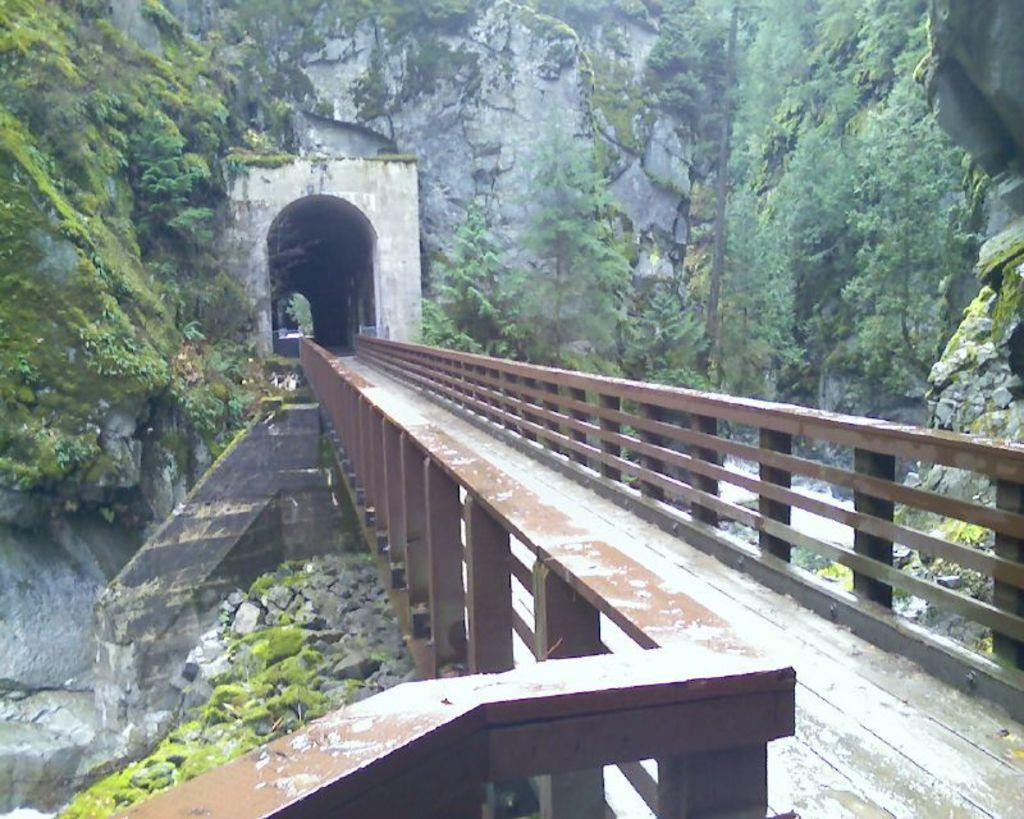What structure is located in the foreground of the image? There is a bridge in the foreground of the image. What can be seen in the background of the image? There is a house and trees in the background of the image. What type of terrain is visible on the right side of the image? There are rocks and grass on the right side of the image. What type of government is depicted in the image? There is no government depicted in the image; it features a bridge, a house, trees, rocks, and grass. Can you see any cracks in the bridge in the image? The provided facts do not mention any cracks in the bridge, so it cannot be determined from the image. 